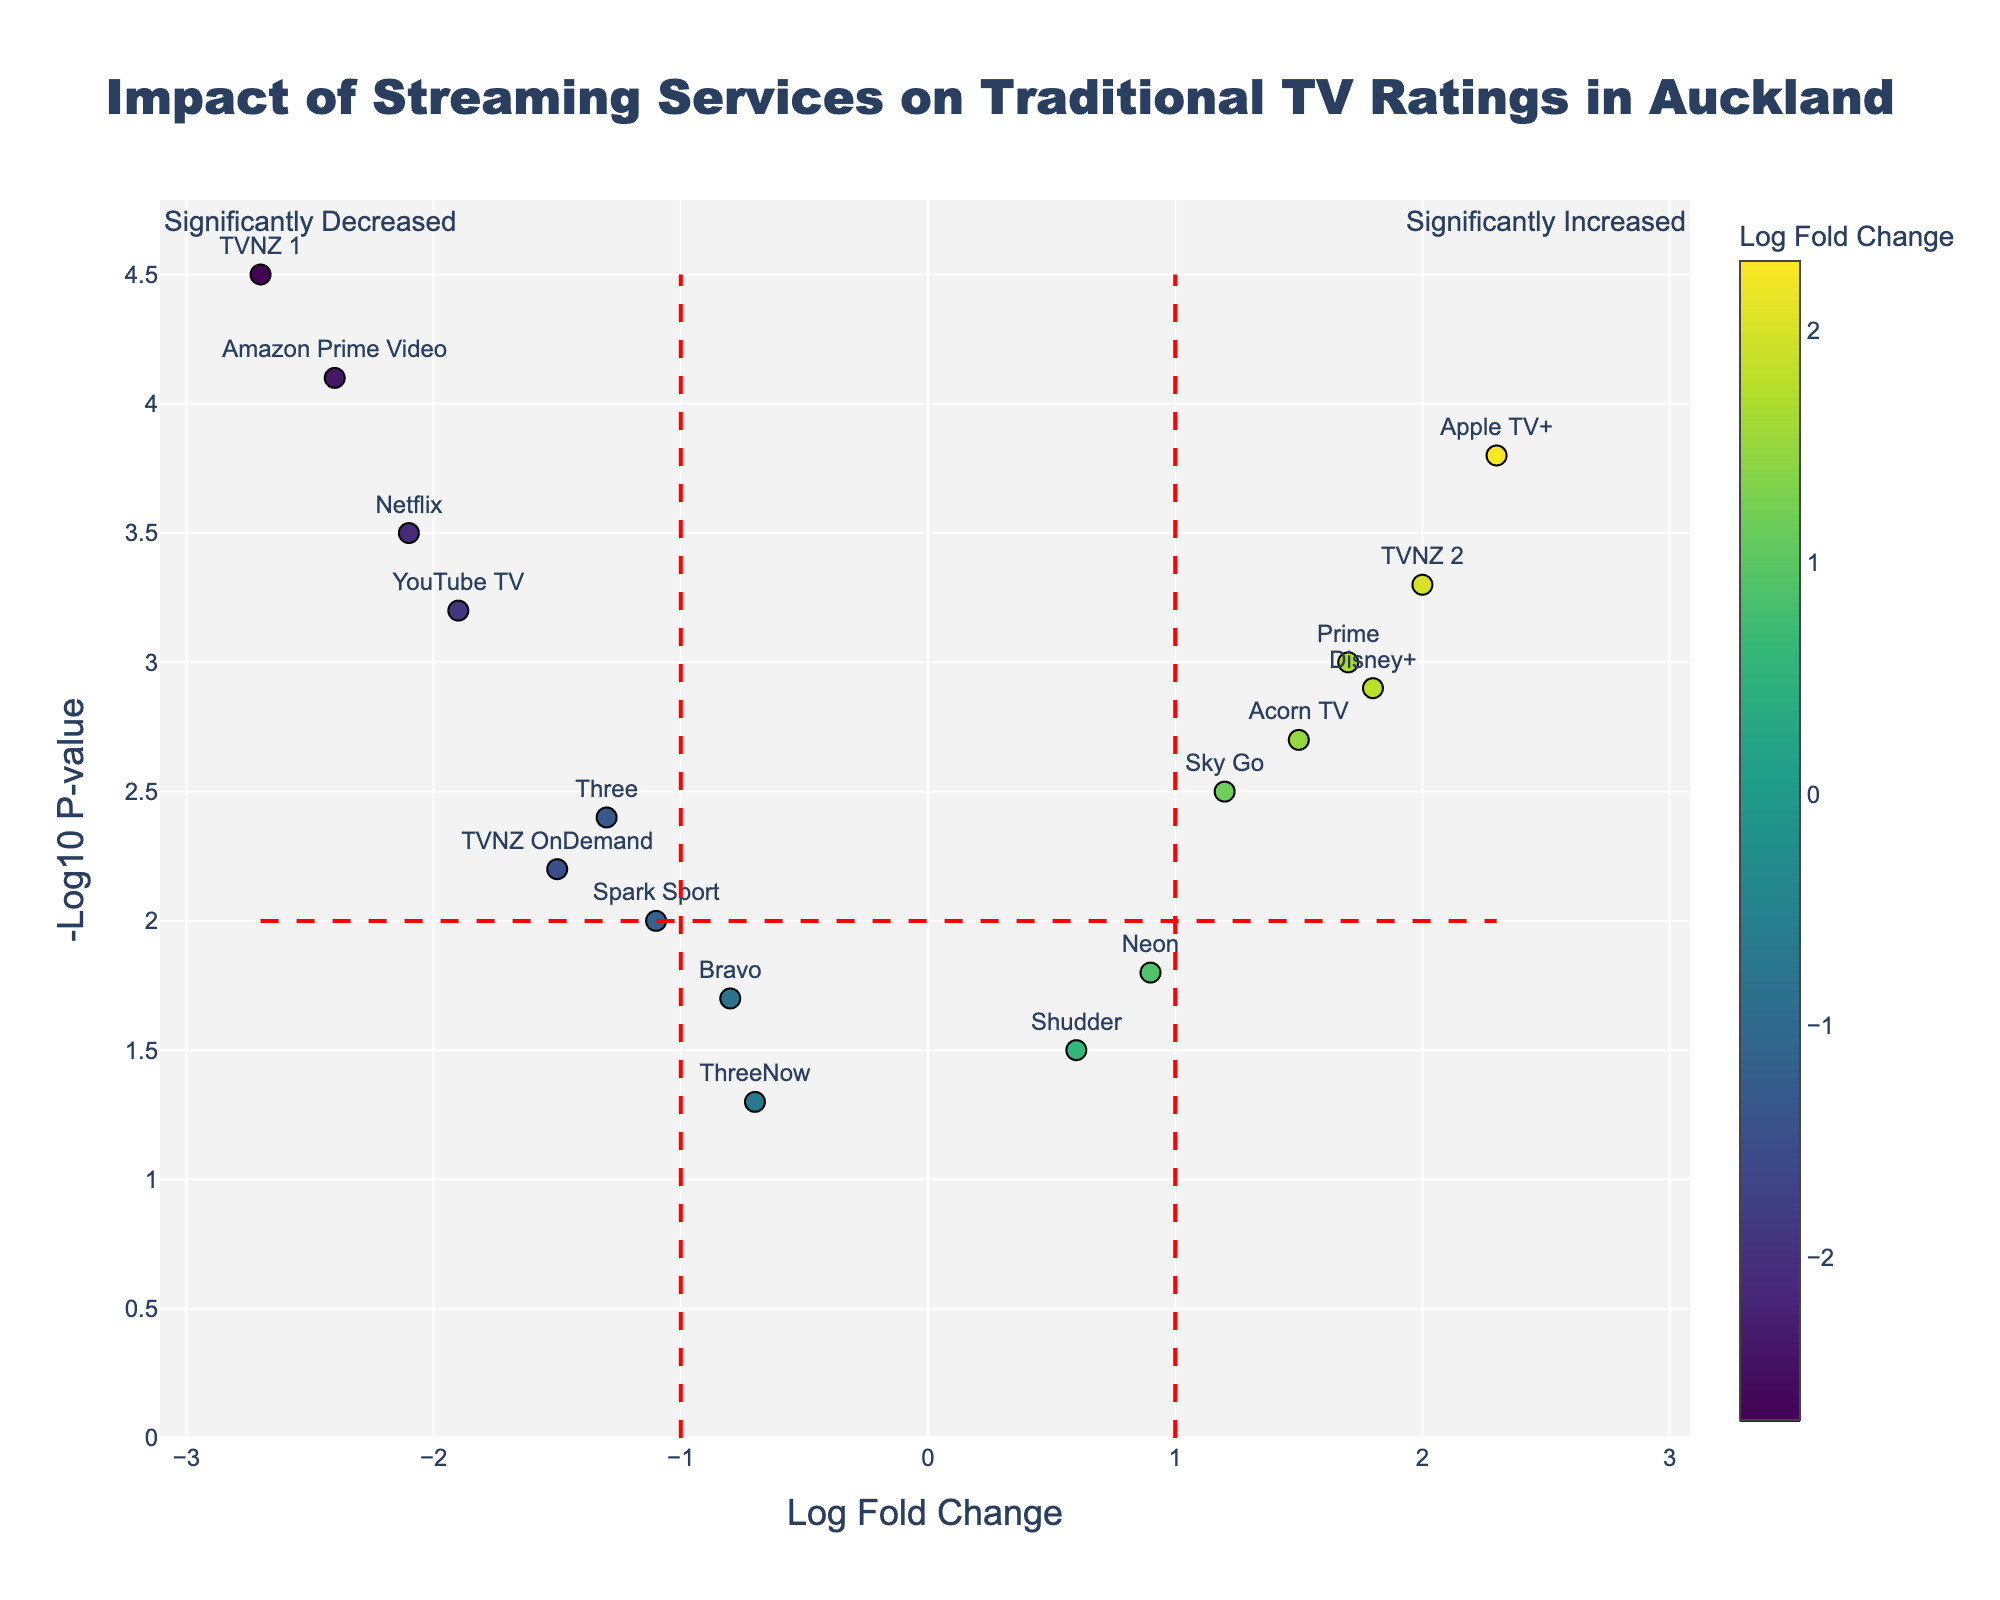What is the title of the plot? The title is positioned at the top of the figure, where it provides a brief description of what the plot represents.
Answer: Impact of Streaming Services on Traditional TV Ratings in Auckland How many data points have a Log Fold Change greater than 1? Identify all points to the right of the vertical line at Log Fold Change = 1. Count the visible data points in that region.
Answer: 5 Which streaming service shows the most significant decrease in traditional TV ratings? Look for the data point with the lowest Log Fold Change and the highest -Log10 P-value in the negative range.
Answer: TVNZ 1 Which streaming service shows both a statistically significant increase (p-value < 0.01) and a Log Fold Change greater than 2? Find the data point in the top-right quadrant with a Log Fold Change > 2 and a -Log10 P-value > 2.
Answer: Apple TV+ What does a high -Log10 P-value indicate about the statistical significance of a data point? A high -Log10 P-value indicates a lower p-value, meaning the result is more statistically significant. For instance, a -Log10 P-value of 2 corresponds to a p-value of 0.01.
Answer: More statistically significant How many streaming services have a Log Fold Change between -1 and 1? Identify and count the data points lying between the vertical red dashed lines at Log Fold Change = -1 and Log Fold Change = 1.
Answer: 5 Which two streaming services are depicted with the lowest -Log10 P-values? Identify the two data points with the lowest positions on the y-axis, indicating a lower -Log10 P-value.
Answer: Shudder and Bravo How is Netflix's impact on traditional TV ratings represented in the plot? Locate the data point labeled Netflix and note its position in terms of Log Fold Change and -Log10 P-value.
Answer: Decreased, -2.1 Log Fold Change and 3.5 -Log10 P-value Which streaming service sits closest to the intersecting point of the red dashed lines at Log Fold Change = 1 and -Log10 P-value = 2? Identify the data point closest to the intersection at (1, 2).
Answer: Acorn TV 